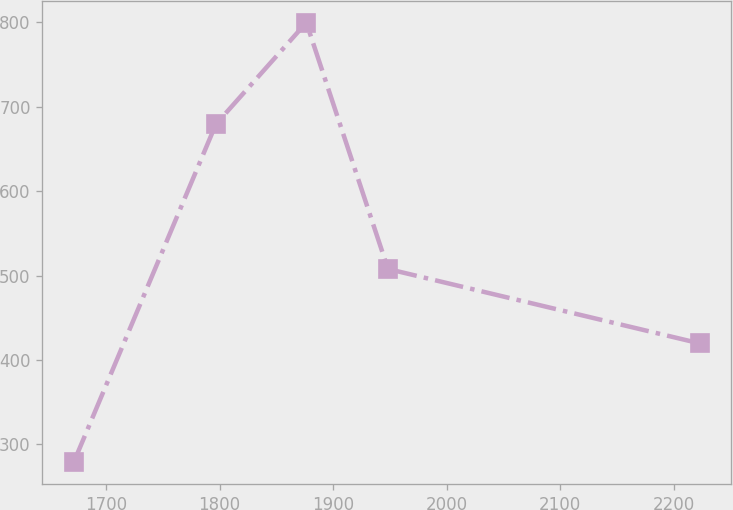Convert chart to OTSL. <chart><loc_0><loc_0><loc_500><loc_500><line_chart><ecel><fcel>Unnamed: 1<nl><fcel>1671.44<fcel>278.72<nl><fcel>1796.7<fcel>679.34<nl><fcel>1876.4<fcel>799.82<nl><fcel>1948.33<fcel>507.89<nl><fcel>2223.15<fcel>419.67<nl></chart> 